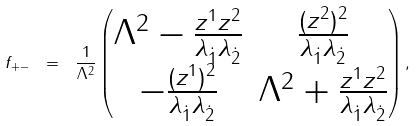Convert formula to latex. <formula><loc_0><loc_0><loc_500><loc_500>f _ { + - } \ = \ \frac { 1 } { \Lambda ^ { 2 } } \begin{pmatrix} \Lambda ^ { 2 } - \frac { z ^ { 1 } z ^ { 2 } } { \lambda _ { \dot { 1 } } \lambda _ { \dot { 2 } } } & \frac { ( z ^ { 2 } ) ^ { 2 } } { \lambda _ { \dot { 1 } } \lambda _ { \dot { 2 } } } \\ - \frac { ( z ^ { 1 } ) ^ { 2 } } { \lambda _ { \dot { 1 } } \lambda _ { \dot { 2 } } } & \Lambda ^ { 2 } + \frac { z ^ { 1 } z ^ { 2 } } { \lambda _ { \dot { 1 } } \lambda _ { \dot { 2 } } } \end{pmatrix} ,</formula> 